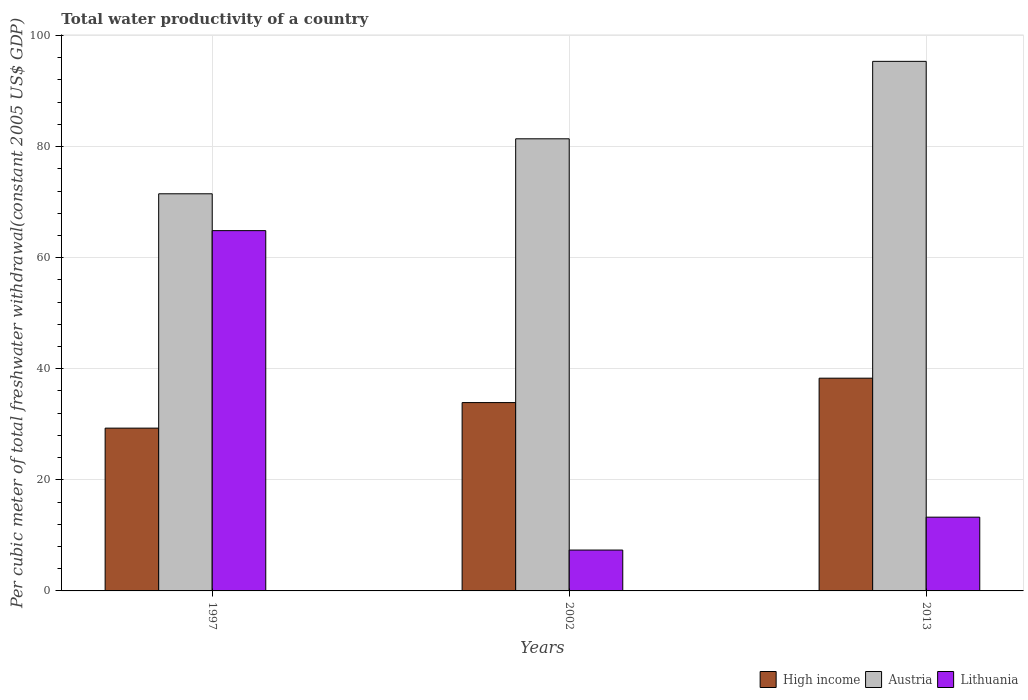How many different coloured bars are there?
Keep it short and to the point. 3. How many groups of bars are there?
Keep it short and to the point. 3. How many bars are there on the 3rd tick from the right?
Your answer should be very brief. 3. What is the total water productivity in Austria in 2002?
Offer a terse response. 81.4. Across all years, what is the maximum total water productivity in Lithuania?
Give a very brief answer. 64.87. Across all years, what is the minimum total water productivity in High income?
Provide a short and direct response. 29.31. In which year was the total water productivity in Austria minimum?
Your response must be concise. 1997. What is the total total water productivity in High income in the graph?
Give a very brief answer. 101.52. What is the difference between the total water productivity in Austria in 2002 and that in 2013?
Your response must be concise. -13.94. What is the difference between the total water productivity in Austria in 2002 and the total water productivity in High income in 2013?
Keep it short and to the point. 43.1. What is the average total water productivity in Austria per year?
Provide a succinct answer. 82.75. In the year 2013, what is the difference between the total water productivity in Lithuania and total water productivity in High income?
Give a very brief answer. -25.02. In how many years, is the total water productivity in High income greater than 8 US$?
Keep it short and to the point. 3. What is the ratio of the total water productivity in Lithuania in 1997 to that in 2013?
Keep it short and to the point. 4.88. What is the difference between the highest and the second highest total water productivity in Austria?
Your answer should be very brief. 13.94. What is the difference between the highest and the lowest total water productivity in High income?
Offer a very short reply. 8.99. What does the 3rd bar from the left in 2002 represents?
Give a very brief answer. Lithuania. What does the 1st bar from the right in 1997 represents?
Offer a terse response. Lithuania. Is it the case that in every year, the sum of the total water productivity in High income and total water productivity in Austria is greater than the total water productivity in Lithuania?
Give a very brief answer. Yes. How many bars are there?
Make the answer very short. 9. How many years are there in the graph?
Provide a short and direct response. 3. What is the difference between two consecutive major ticks on the Y-axis?
Provide a succinct answer. 20. Are the values on the major ticks of Y-axis written in scientific E-notation?
Your answer should be very brief. No. Does the graph contain any zero values?
Provide a succinct answer. No. What is the title of the graph?
Provide a succinct answer. Total water productivity of a country. What is the label or title of the X-axis?
Your response must be concise. Years. What is the label or title of the Y-axis?
Your answer should be very brief. Per cubic meter of total freshwater withdrawal(constant 2005 US$ GDP). What is the Per cubic meter of total freshwater withdrawal(constant 2005 US$ GDP) in High income in 1997?
Your response must be concise. 29.31. What is the Per cubic meter of total freshwater withdrawal(constant 2005 US$ GDP) in Austria in 1997?
Your answer should be very brief. 71.5. What is the Per cubic meter of total freshwater withdrawal(constant 2005 US$ GDP) in Lithuania in 1997?
Your answer should be compact. 64.87. What is the Per cubic meter of total freshwater withdrawal(constant 2005 US$ GDP) of High income in 2002?
Give a very brief answer. 33.91. What is the Per cubic meter of total freshwater withdrawal(constant 2005 US$ GDP) of Austria in 2002?
Keep it short and to the point. 81.4. What is the Per cubic meter of total freshwater withdrawal(constant 2005 US$ GDP) in Lithuania in 2002?
Provide a short and direct response. 7.36. What is the Per cubic meter of total freshwater withdrawal(constant 2005 US$ GDP) in High income in 2013?
Provide a succinct answer. 38.3. What is the Per cubic meter of total freshwater withdrawal(constant 2005 US$ GDP) of Austria in 2013?
Your response must be concise. 95.35. What is the Per cubic meter of total freshwater withdrawal(constant 2005 US$ GDP) in Lithuania in 2013?
Offer a very short reply. 13.28. Across all years, what is the maximum Per cubic meter of total freshwater withdrawal(constant 2005 US$ GDP) of High income?
Your answer should be compact. 38.3. Across all years, what is the maximum Per cubic meter of total freshwater withdrawal(constant 2005 US$ GDP) of Austria?
Your response must be concise. 95.35. Across all years, what is the maximum Per cubic meter of total freshwater withdrawal(constant 2005 US$ GDP) of Lithuania?
Offer a terse response. 64.87. Across all years, what is the minimum Per cubic meter of total freshwater withdrawal(constant 2005 US$ GDP) in High income?
Your answer should be very brief. 29.31. Across all years, what is the minimum Per cubic meter of total freshwater withdrawal(constant 2005 US$ GDP) of Austria?
Offer a very short reply. 71.5. Across all years, what is the minimum Per cubic meter of total freshwater withdrawal(constant 2005 US$ GDP) of Lithuania?
Your response must be concise. 7.36. What is the total Per cubic meter of total freshwater withdrawal(constant 2005 US$ GDP) of High income in the graph?
Make the answer very short. 101.52. What is the total Per cubic meter of total freshwater withdrawal(constant 2005 US$ GDP) in Austria in the graph?
Your answer should be compact. 248.25. What is the total Per cubic meter of total freshwater withdrawal(constant 2005 US$ GDP) of Lithuania in the graph?
Your response must be concise. 85.51. What is the difference between the Per cubic meter of total freshwater withdrawal(constant 2005 US$ GDP) of High income in 1997 and that in 2002?
Your answer should be compact. -4.6. What is the difference between the Per cubic meter of total freshwater withdrawal(constant 2005 US$ GDP) in Austria in 1997 and that in 2002?
Give a very brief answer. -9.9. What is the difference between the Per cubic meter of total freshwater withdrawal(constant 2005 US$ GDP) of Lithuania in 1997 and that in 2002?
Provide a short and direct response. 57.51. What is the difference between the Per cubic meter of total freshwater withdrawal(constant 2005 US$ GDP) in High income in 1997 and that in 2013?
Provide a succinct answer. -8.99. What is the difference between the Per cubic meter of total freshwater withdrawal(constant 2005 US$ GDP) in Austria in 1997 and that in 2013?
Make the answer very short. -23.84. What is the difference between the Per cubic meter of total freshwater withdrawal(constant 2005 US$ GDP) in Lithuania in 1997 and that in 2013?
Give a very brief answer. 51.59. What is the difference between the Per cubic meter of total freshwater withdrawal(constant 2005 US$ GDP) in High income in 2002 and that in 2013?
Your answer should be very brief. -4.39. What is the difference between the Per cubic meter of total freshwater withdrawal(constant 2005 US$ GDP) in Austria in 2002 and that in 2013?
Offer a terse response. -13.94. What is the difference between the Per cubic meter of total freshwater withdrawal(constant 2005 US$ GDP) in Lithuania in 2002 and that in 2013?
Offer a terse response. -5.92. What is the difference between the Per cubic meter of total freshwater withdrawal(constant 2005 US$ GDP) of High income in 1997 and the Per cubic meter of total freshwater withdrawal(constant 2005 US$ GDP) of Austria in 2002?
Give a very brief answer. -52.09. What is the difference between the Per cubic meter of total freshwater withdrawal(constant 2005 US$ GDP) in High income in 1997 and the Per cubic meter of total freshwater withdrawal(constant 2005 US$ GDP) in Lithuania in 2002?
Give a very brief answer. 21.95. What is the difference between the Per cubic meter of total freshwater withdrawal(constant 2005 US$ GDP) in Austria in 1997 and the Per cubic meter of total freshwater withdrawal(constant 2005 US$ GDP) in Lithuania in 2002?
Provide a short and direct response. 64.14. What is the difference between the Per cubic meter of total freshwater withdrawal(constant 2005 US$ GDP) in High income in 1997 and the Per cubic meter of total freshwater withdrawal(constant 2005 US$ GDP) in Austria in 2013?
Provide a succinct answer. -66.04. What is the difference between the Per cubic meter of total freshwater withdrawal(constant 2005 US$ GDP) of High income in 1997 and the Per cubic meter of total freshwater withdrawal(constant 2005 US$ GDP) of Lithuania in 2013?
Provide a succinct answer. 16.03. What is the difference between the Per cubic meter of total freshwater withdrawal(constant 2005 US$ GDP) of Austria in 1997 and the Per cubic meter of total freshwater withdrawal(constant 2005 US$ GDP) of Lithuania in 2013?
Provide a short and direct response. 58.22. What is the difference between the Per cubic meter of total freshwater withdrawal(constant 2005 US$ GDP) in High income in 2002 and the Per cubic meter of total freshwater withdrawal(constant 2005 US$ GDP) in Austria in 2013?
Ensure brevity in your answer.  -61.44. What is the difference between the Per cubic meter of total freshwater withdrawal(constant 2005 US$ GDP) in High income in 2002 and the Per cubic meter of total freshwater withdrawal(constant 2005 US$ GDP) in Lithuania in 2013?
Your response must be concise. 20.63. What is the difference between the Per cubic meter of total freshwater withdrawal(constant 2005 US$ GDP) of Austria in 2002 and the Per cubic meter of total freshwater withdrawal(constant 2005 US$ GDP) of Lithuania in 2013?
Provide a short and direct response. 68.12. What is the average Per cubic meter of total freshwater withdrawal(constant 2005 US$ GDP) of High income per year?
Offer a very short reply. 33.84. What is the average Per cubic meter of total freshwater withdrawal(constant 2005 US$ GDP) of Austria per year?
Provide a succinct answer. 82.75. What is the average Per cubic meter of total freshwater withdrawal(constant 2005 US$ GDP) in Lithuania per year?
Ensure brevity in your answer.  28.5. In the year 1997, what is the difference between the Per cubic meter of total freshwater withdrawal(constant 2005 US$ GDP) in High income and Per cubic meter of total freshwater withdrawal(constant 2005 US$ GDP) in Austria?
Your response must be concise. -42.19. In the year 1997, what is the difference between the Per cubic meter of total freshwater withdrawal(constant 2005 US$ GDP) of High income and Per cubic meter of total freshwater withdrawal(constant 2005 US$ GDP) of Lithuania?
Your answer should be compact. -35.56. In the year 1997, what is the difference between the Per cubic meter of total freshwater withdrawal(constant 2005 US$ GDP) in Austria and Per cubic meter of total freshwater withdrawal(constant 2005 US$ GDP) in Lithuania?
Offer a terse response. 6.63. In the year 2002, what is the difference between the Per cubic meter of total freshwater withdrawal(constant 2005 US$ GDP) of High income and Per cubic meter of total freshwater withdrawal(constant 2005 US$ GDP) of Austria?
Your response must be concise. -47.49. In the year 2002, what is the difference between the Per cubic meter of total freshwater withdrawal(constant 2005 US$ GDP) of High income and Per cubic meter of total freshwater withdrawal(constant 2005 US$ GDP) of Lithuania?
Ensure brevity in your answer.  26.55. In the year 2002, what is the difference between the Per cubic meter of total freshwater withdrawal(constant 2005 US$ GDP) of Austria and Per cubic meter of total freshwater withdrawal(constant 2005 US$ GDP) of Lithuania?
Your response must be concise. 74.04. In the year 2013, what is the difference between the Per cubic meter of total freshwater withdrawal(constant 2005 US$ GDP) of High income and Per cubic meter of total freshwater withdrawal(constant 2005 US$ GDP) of Austria?
Your answer should be very brief. -57.04. In the year 2013, what is the difference between the Per cubic meter of total freshwater withdrawal(constant 2005 US$ GDP) of High income and Per cubic meter of total freshwater withdrawal(constant 2005 US$ GDP) of Lithuania?
Offer a terse response. 25.02. In the year 2013, what is the difference between the Per cubic meter of total freshwater withdrawal(constant 2005 US$ GDP) in Austria and Per cubic meter of total freshwater withdrawal(constant 2005 US$ GDP) in Lithuania?
Keep it short and to the point. 82.07. What is the ratio of the Per cubic meter of total freshwater withdrawal(constant 2005 US$ GDP) in High income in 1997 to that in 2002?
Keep it short and to the point. 0.86. What is the ratio of the Per cubic meter of total freshwater withdrawal(constant 2005 US$ GDP) in Austria in 1997 to that in 2002?
Offer a very short reply. 0.88. What is the ratio of the Per cubic meter of total freshwater withdrawal(constant 2005 US$ GDP) in Lithuania in 1997 to that in 2002?
Your answer should be compact. 8.81. What is the ratio of the Per cubic meter of total freshwater withdrawal(constant 2005 US$ GDP) of High income in 1997 to that in 2013?
Make the answer very short. 0.77. What is the ratio of the Per cubic meter of total freshwater withdrawal(constant 2005 US$ GDP) of Austria in 1997 to that in 2013?
Your response must be concise. 0.75. What is the ratio of the Per cubic meter of total freshwater withdrawal(constant 2005 US$ GDP) in Lithuania in 1997 to that in 2013?
Your response must be concise. 4.88. What is the ratio of the Per cubic meter of total freshwater withdrawal(constant 2005 US$ GDP) of High income in 2002 to that in 2013?
Your answer should be compact. 0.89. What is the ratio of the Per cubic meter of total freshwater withdrawal(constant 2005 US$ GDP) of Austria in 2002 to that in 2013?
Ensure brevity in your answer.  0.85. What is the ratio of the Per cubic meter of total freshwater withdrawal(constant 2005 US$ GDP) in Lithuania in 2002 to that in 2013?
Your answer should be very brief. 0.55. What is the difference between the highest and the second highest Per cubic meter of total freshwater withdrawal(constant 2005 US$ GDP) of High income?
Offer a very short reply. 4.39. What is the difference between the highest and the second highest Per cubic meter of total freshwater withdrawal(constant 2005 US$ GDP) of Austria?
Make the answer very short. 13.94. What is the difference between the highest and the second highest Per cubic meter of total freshwater withdrawal(constant 2005 US$ GDP) of Lithuania?
Ensure brevity in your answer.  51.59. What is the difference between the highest and the lowest Per cubic meter of total freshwater withdrawal(constant 2005 US$ GDP) in High income?
Your answer should be very brief. 8.99. What is the difference between the highest and the lowest Per cubic meter of total freshwater withdrawal(constant 2005 US$ GDP) of Austria?
Provide a short and direct response. 23.84. What is the difference between the highest and the lowest Per cubic meter of total freshwater withdrawal(constant 2005 US$ GDP) of Lithuania?
Your response must be concise. 57.51. 